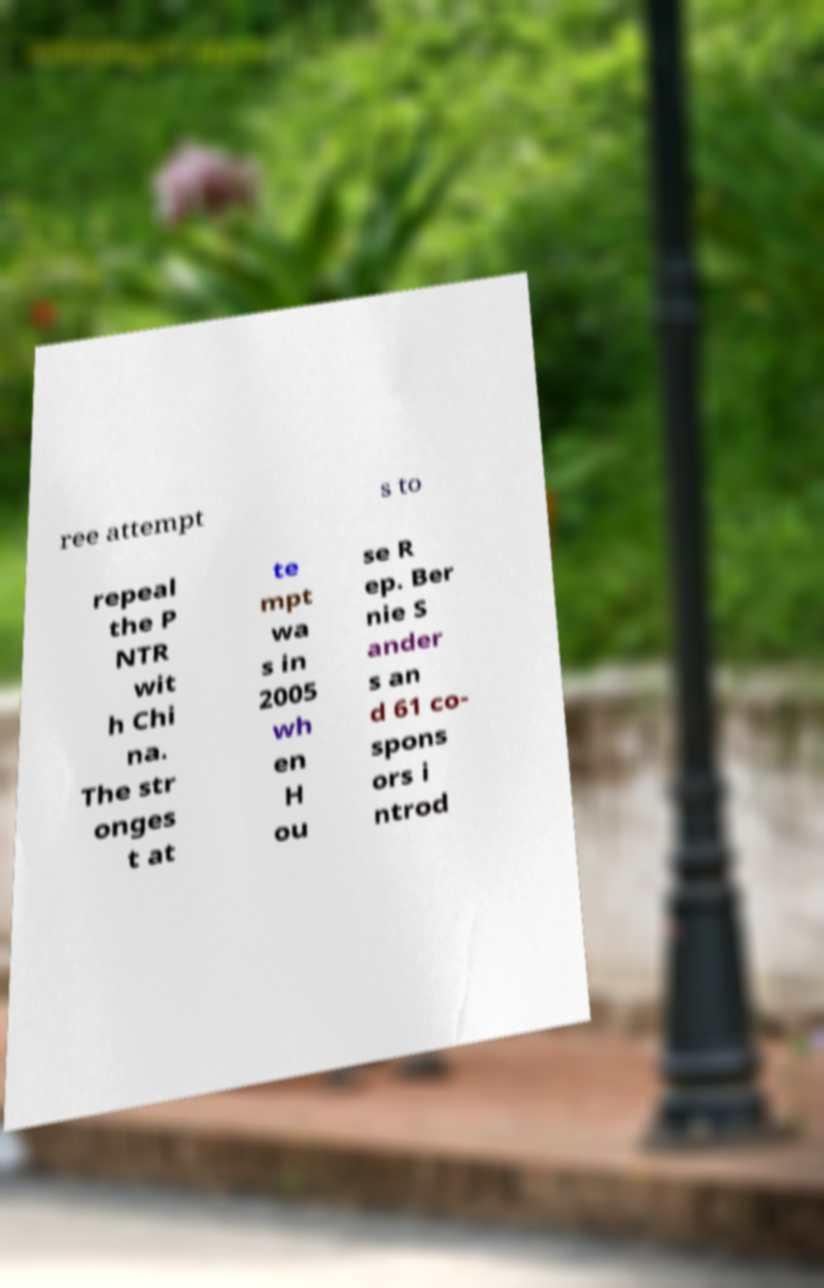Could you extract and type out the text from this image? ree attempt s to repeal the P NTR wit h Chi na. The str onges t at te mpt wa s in 2005 wh en H ou se R ep. Ber nie S ander s an d 61 co- spons ors i ntrod 